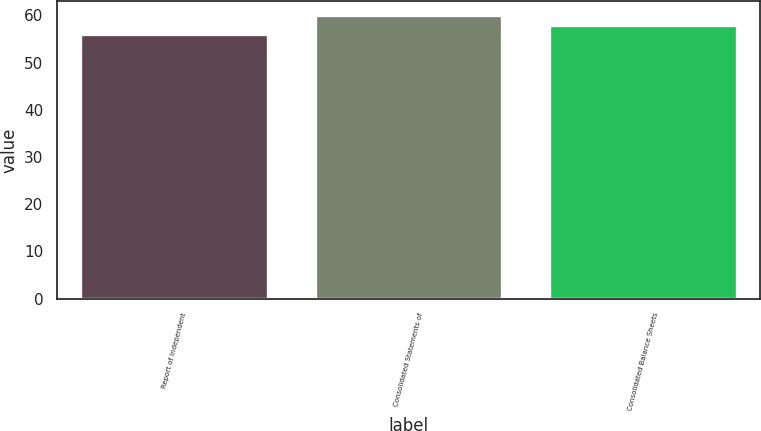<chart> <loc_0><loc_0><loc_500><loc_500><bar_chart><fcel>Report of Independent<fcel>Consolidated Statements of<fcel>Consolidated Balance Sheets<nl><fcel>56<fcel>60<fcel>58<nl></chart> 